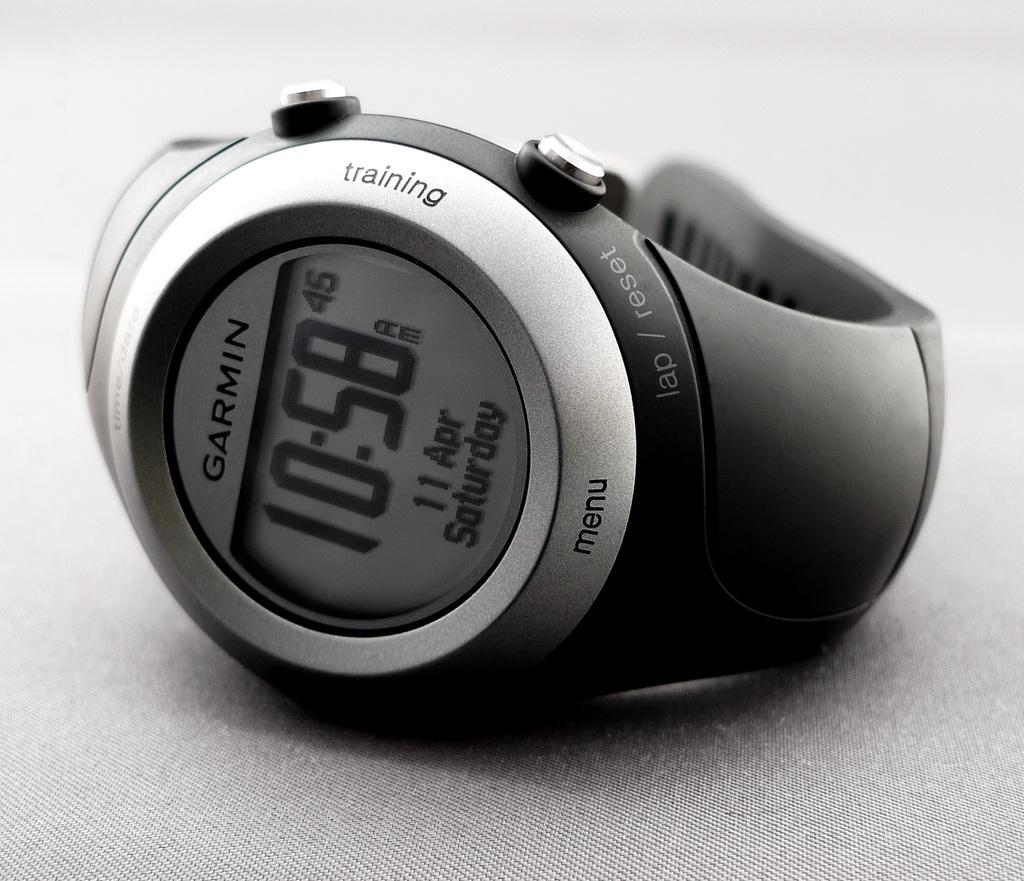What time is on the watch?
Your answer should be compact. 10:58. What brand is this watch?
Offer a very short reply. Garmin. 